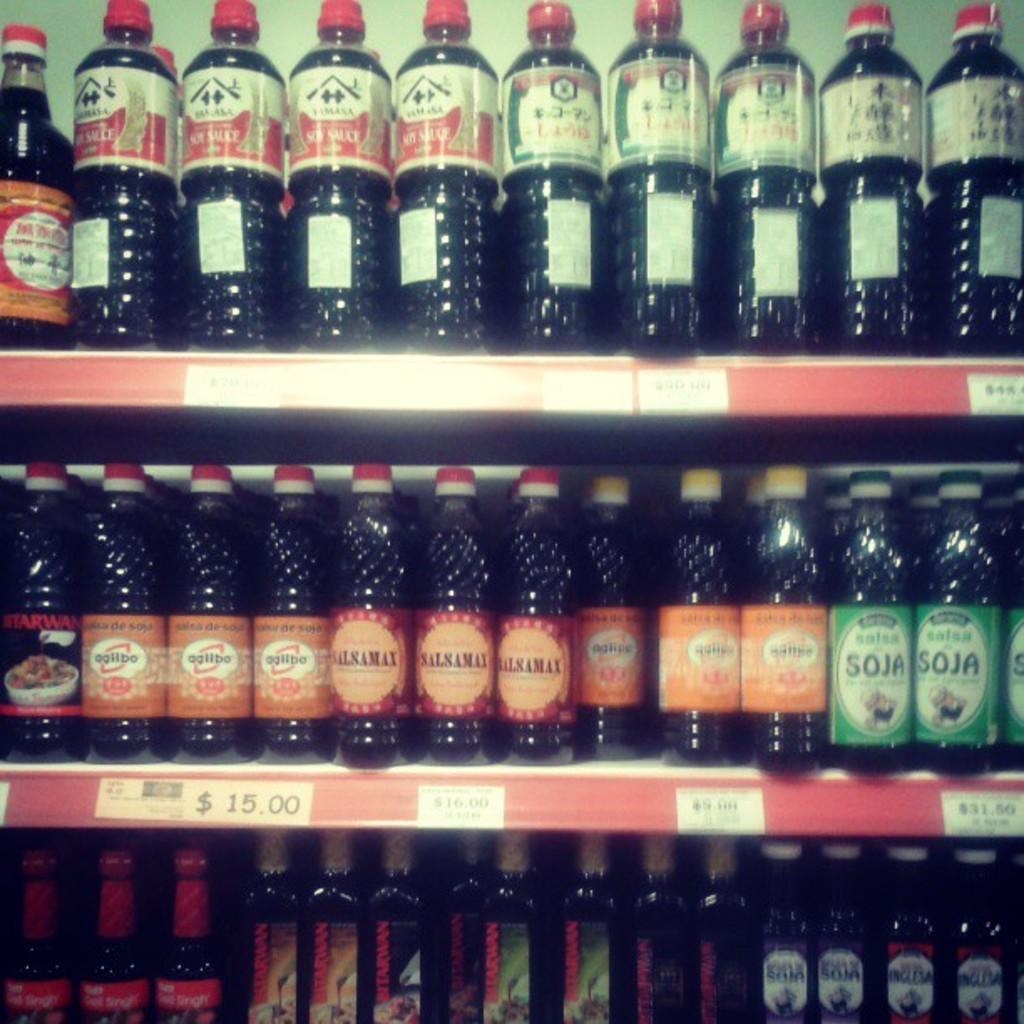<image>
Describe the image concisely. Bottles of Soja Salsa are lined up on a shelf. 